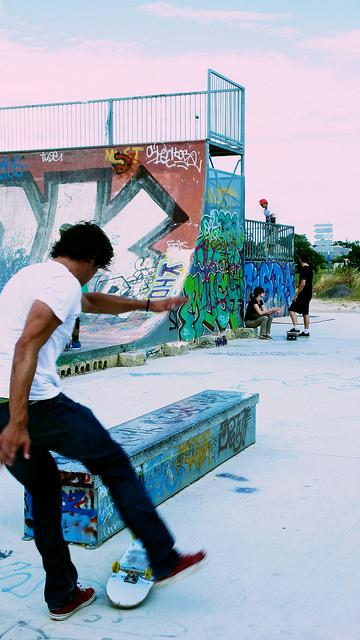What is the large ramp used for?

Choices:
A) basketball
B) skateboarding
C) football
D) sledding skateboarding 